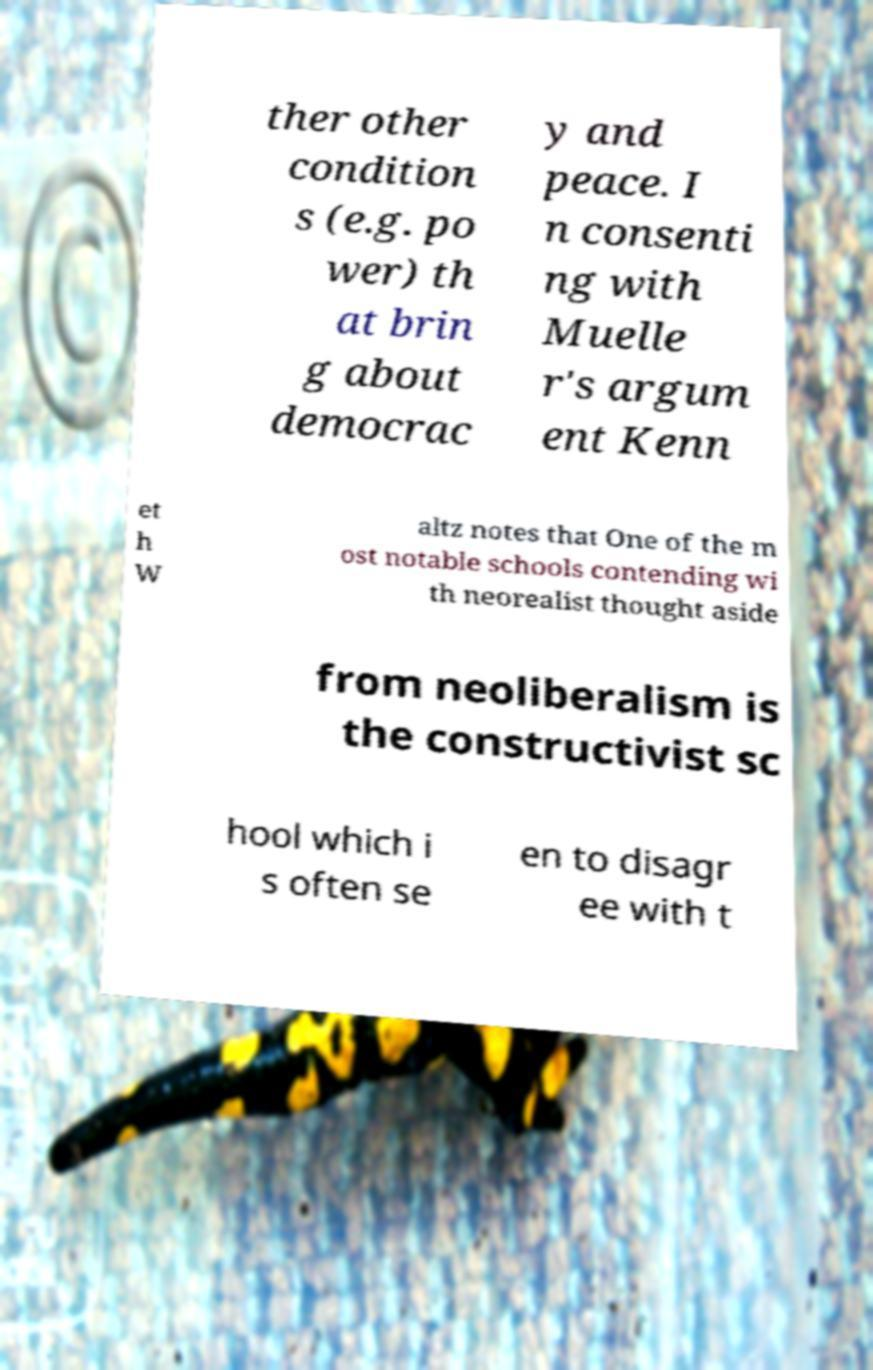Could you extract and type out the text from this image? ther other condition s (e.g. po wer) th at brin g about democrac y and peace. I n consenti ng with Muelle r's argum ent Kenn et h W altz notes that One of the m ost notable schools contending wi th neorealist thought aside from neoliberalism is the constructivist sc hool which i s often se en to disagr ee with t 